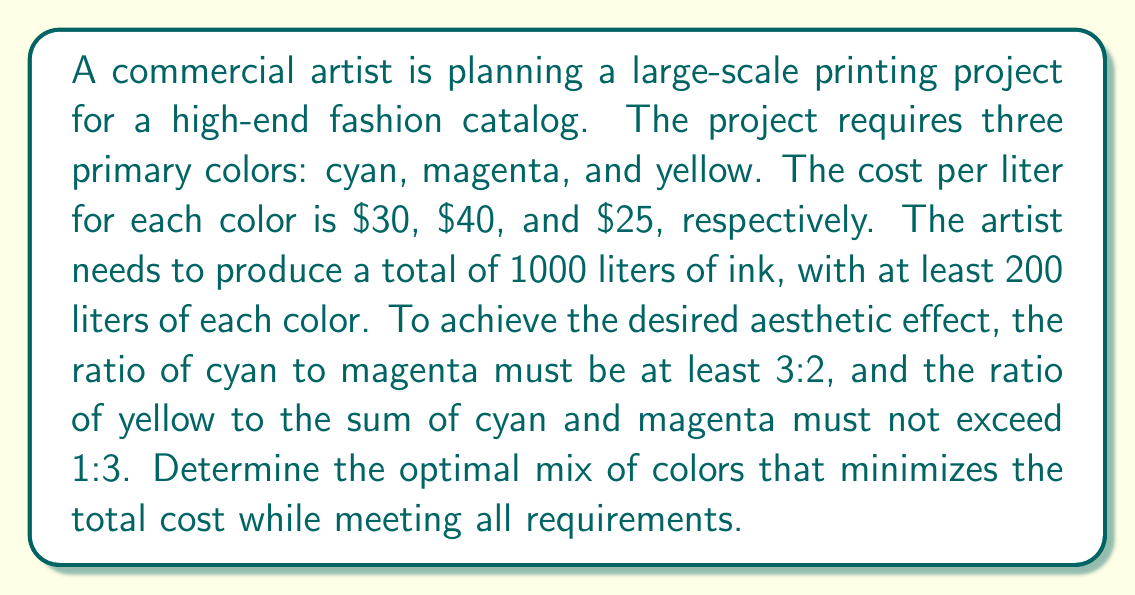Provide a solution to this math problem. Let's approach this problem using linear programming:

1. Define variables:
   $x$ = liters of cyan
   $y$ = liters of magenta
   $z$ = liters of yellow

2. Objective function (minimize cost):
   $\text{Minimize } 30x + 40y + 25z$

3. Constraints:
   a) Total volume: $x + y + z = 1000$
   b) Minimum amounts: $x \geq 200$, $y \geq 200$, $z \geq 200$
   c) Cyan to magenta ratio: $x \geq \frac{3}{2}y$
   d) Yellow to cyan+magenta ratio: $z \leq \frac{1}{3}(x + y)$

4. Solve using the simplex method or a linear programming solver:

   The optimal solution is:
   $x = 450$ (cyan)
   $y = 300$ (magenta)
   $z = 250$ (yellow)

5. Verify constraints:
   a) $450 + 300 + 250 = 1000$ (satisfied)
   b) All colors exceed 200 liters (satisfied)
   c) $450 \geq \frac{3}{2}(300)$ (satisfied)
   d) $250 \leq \frac{1}{3}(450 + 300)$ (satisfied)

6. Calculate total cost:
   $30(450) + 40(300) + 25(250) = 13,500 + 12,000 + 6,250 = 31,750$

This solution minimizes cost while meeting all aesthetic and production requirements.
Answer: The optimal mix is 450 liters of cyan, 300 liters of magenta, and 250 liters of yellow, with a total cost of $31,750. 